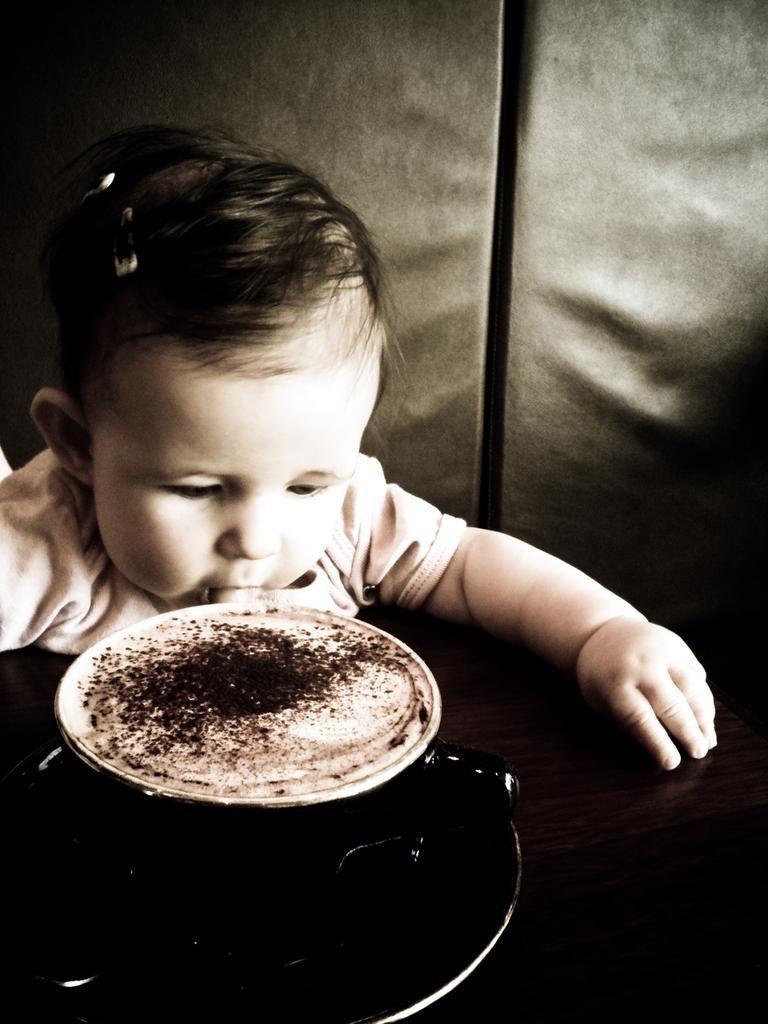How would you summarize this image in a sentence or two? In this picture we can see a kid, in front of the kid we can find a cup with drink in it. 